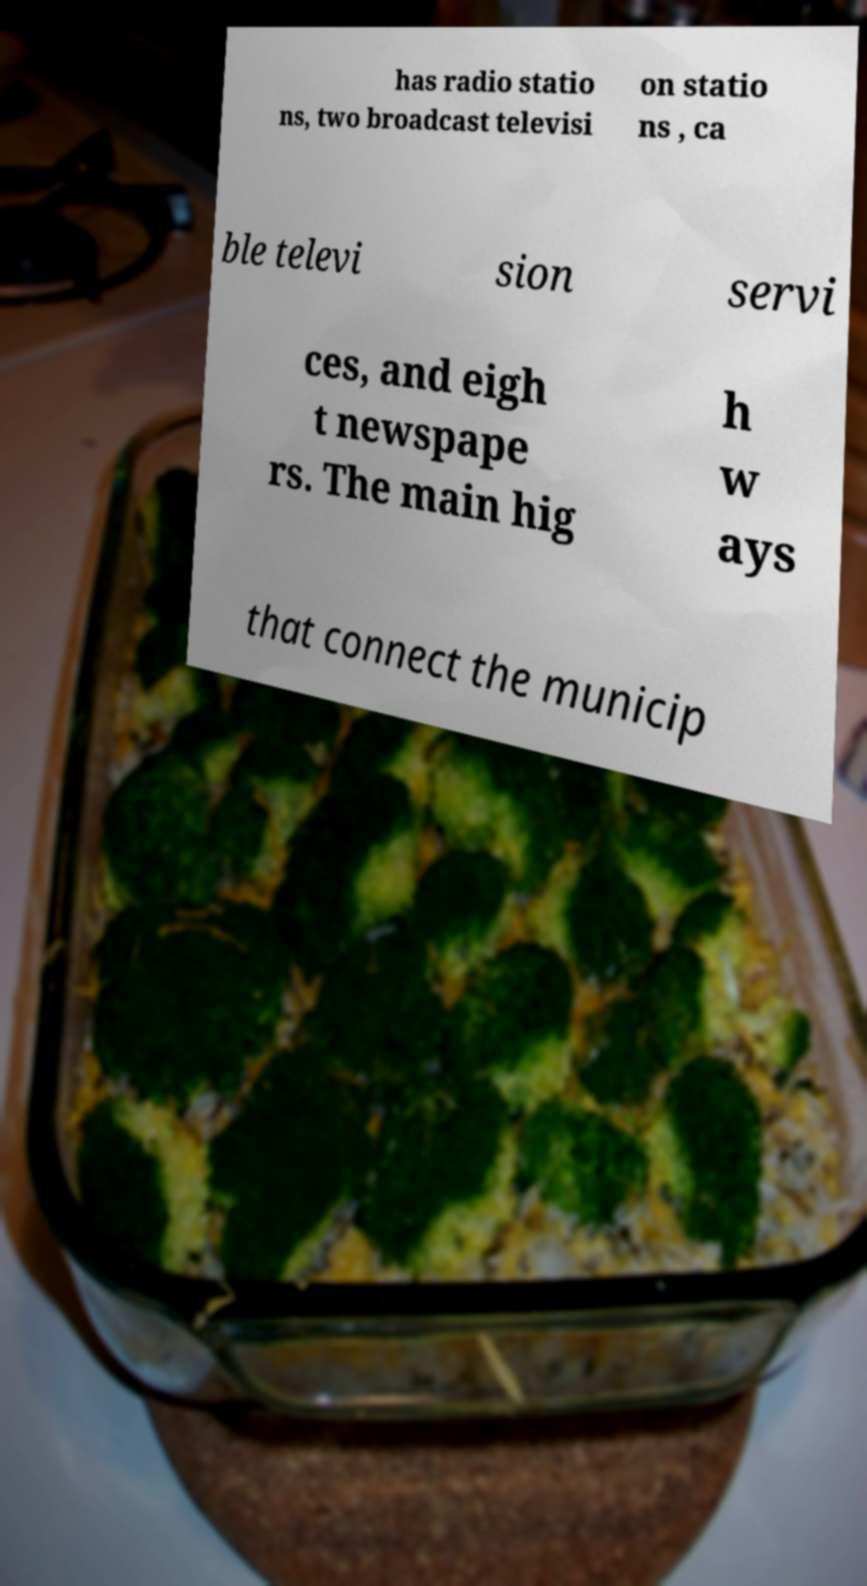There's text embedded in this image that I need extracted. Can you transcribe it verbatim? has radio statio ns, two broadcast televisi on statio ns , ca ble televi sion servi ces, and eigh t newspape rs. The main hig h w ays that connect the municip 